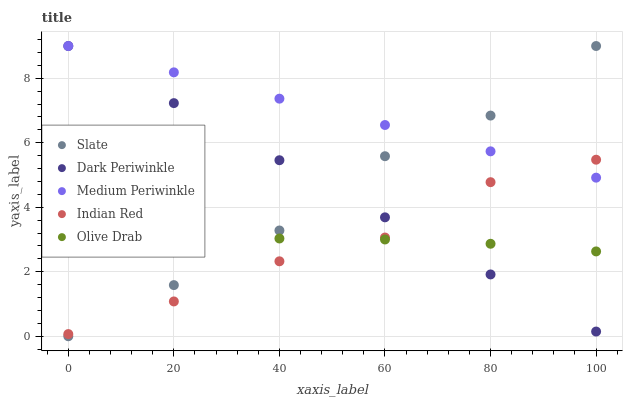Does Indian Red have the minimum area under the curve?
Answer yes or no. Yes. Does Medium Periwinkle have the maximum area under the curve?
Answer yes or no. Yes. Does Slate have the minimum area under the curve?
Answer yes or no. No. Does Slate have the maximum area under the curve?
Answer yes or no. No. Is Dark Periwinkle the smoothest?
Answer yes or no. Yes. Is Indian Red the roughest?
Answer yes or no. Yes. Is Slate the smoothest?
Answer yes or no. No. Is Slate the roughest?
Answer yes or no. No. Does Slate have the lowest value?
Answer yes or no. Yes. Does Medium Periwinkle have the lowest value?
Answer yes or no. No. Does Dark Periwinkle have the highest value?
Answer yes or no. Yes. Does Indian Red have the highest value?
Answer yes or no. No. Is Olive Drab less than Medium Periwinkle?
Answer yes or no. Yes. Is Medium Periwinkle greater than Olive Drab?
Answer yes or no. Yes. Does Slate intersect Dark Periwinkle?
Answer yes or no. Yes. Is Slate less than Dark Periwinkle?
Answer yes or no. No. Is Slate greater than Dark Periwinkle?
Answer yes or no. No. Does Olive Drab intersect Medium Periwinkle?
Answer yes or no. No. 